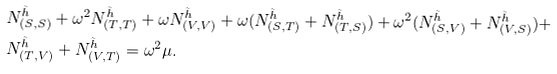<formula> <loc_0><loc_0><loc_500><loc_500>& N _ { ( S , S ) } ^ { \tilde { h } } + \omega ^ { 2 } N _ { ( T , T ) } ^ { \tilde { h } } + \omega N _ { ( V , V ) } ^ { \tilde { h } } + \omega ( N _ { ( S , T ) } ^ { \tilde { h } } + N _ { ( T , S ) } ^ { \tilde { h } } ) + \omega ^ { 2 } ( N _ { ( S , V ) } ^ { \tilde { h } } + N _ { ( V , S ) } ^ { \tilde { h } } ) + \\ & N _ { ( T , V ) } ^ { \tilde { h } } + N _ { ( V , T ) } ^ { \tilde { h } } = \omega ^ { 2 } \mu .</formula> 